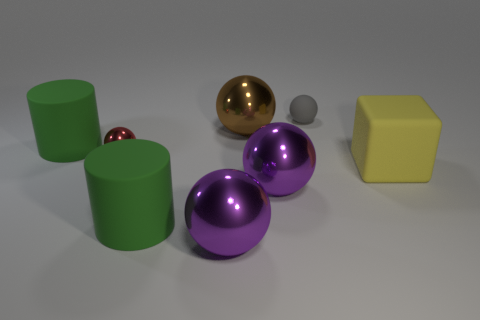The other tiny thing that is the same material as the yellow object is what color?
Your response must be concise. Gray. What is the material of the large brown sphere?
Provide a succinct answer. Metal. What is the shape of the red object?
Offer a very short reply. Sphere. How many matte cubes are the same color as the tiny rubber sphere?
Ensure brevity in your answer.  0. There is a large object in front of the green cylinder that is in front of the small object in front of the small gray thing; what is its material?
Offer a very short reply. Metal. What number of green objects are either big spheres or cubes?
Ensure brevity in your answer.  0. What is the size of the green cylinder that is left of the green cylinder in front of the matte object on the right side of the gray matte sphere?
Your answer should be very brief. Large. The other brown object that is the same shape as the tiny metal object is what size?
Your response must be concise. Large. How many small objects are either cubes or red metal objects?
Your response must be concise. 1. Is the green cylinder that is right of the small metallic thing made of the same material as the large thing that is right of the tiny gray object?
Ensure brevity in your answer.  Yes. 